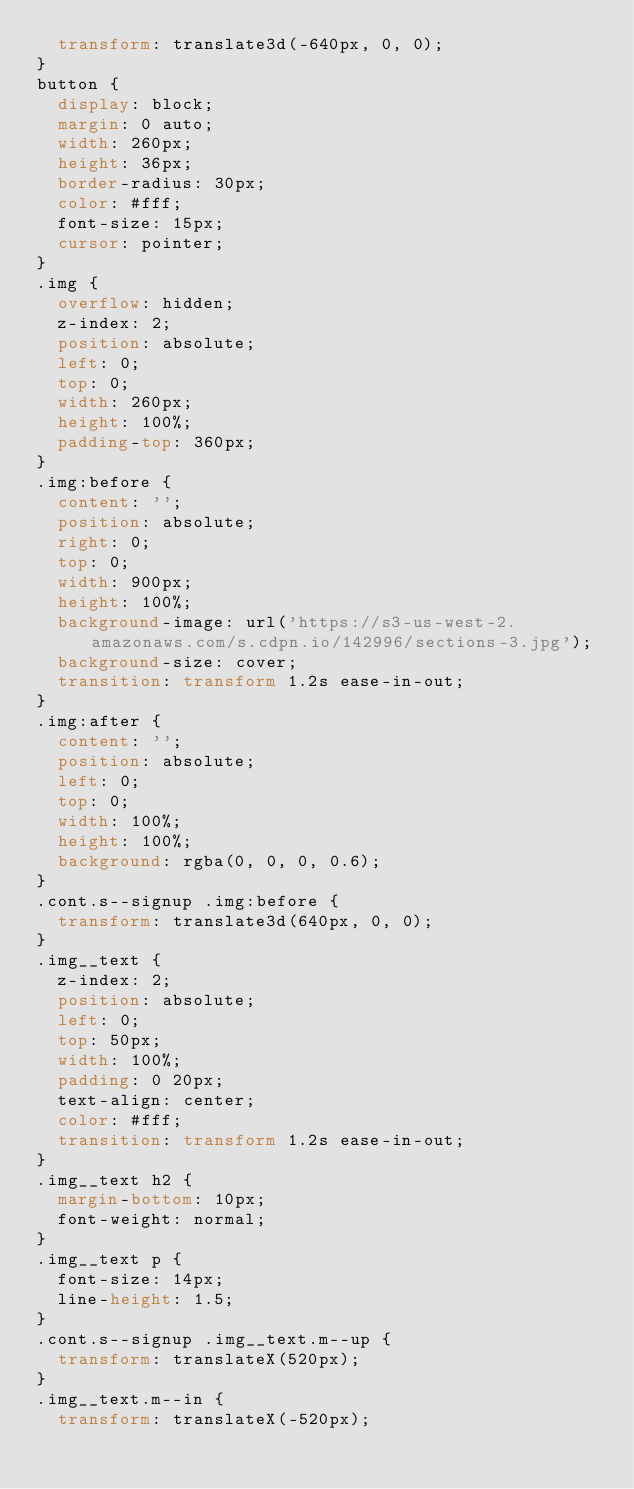<code> <loc_0><loc_0><loc_500><loc_500><_CSS_>  transform: translate3d(-640px, 0, 0);
}
button {
  display: block;
  margin: 0 auto;
  width: 260px;
  height: 36px;
  border-radius: 30px;
  color: #fff;
  font-size: 15px;
  cursor: pointer;
}
.img {
  overflow: hidden;
  z-index: 2;
  position: absolute;
  left: 0;
  top: 0;
  width: 260px;
  height: 100%;
  padding-top: 360px;
}
.img:before {
  content: '';
  position: absolute;
  right: 0;
  top: 0;
  width: 900px;
  height: 100%;
  background-image: url('https://s3-us-west-2.amazonaws.com/s.cdpn.io/142996/sections-3.jpg');
  background-size: cover;
  transition: transform 1.2s ease-in-out;
}
.img:after {
  content: '';
  position: absolute;
  left: 0;
  top: 0;
  width: 100%;
  height: 100%;
  background: rgba(0, 0, 0, 0.6);
}
.cont.s--signup .img:before {
  transform: translate3d(640px, 0, 0);
}
.img__text {
  z-index: 2;
  position: absolute;
  left: 0;
  top: 50px;
  width: 100%;
  padding: 0 20px;
  text-align: center;
  color: #fff;
  transition: transform 1.2s ease-in-out;
}
.img__text h2 {
  margin-bottom: 10px;
  font-weight: normal;
}
.img__text p {
  font-size: 14px;
  line-height: 1.5;
}
.cont.s--signup .img__text.m--up {
  transform: translateX(520px);
}
.img__text.m--in {
  transform: translateX(-520px);</code> 